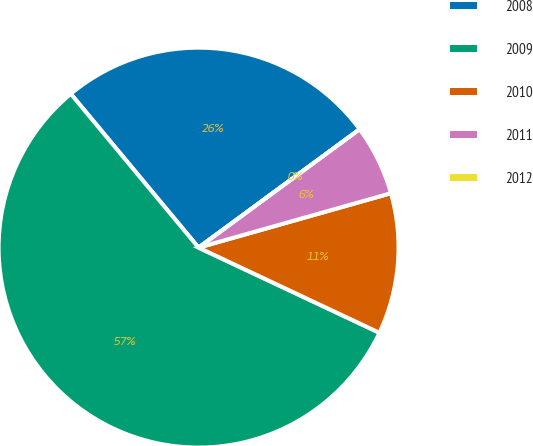Convert chart to OTSL. <chart><loc_0><loc_0><loc_500><loc_500><pie_chart><fcel>2008<fcel>2009<fcel>2010<fcel>2011<fcel>2012<nl><fcel>25.95%<fcel>56.96%<fcel>11.39%<fcel>5.7%<fcel>0.0%<nl></chart> 